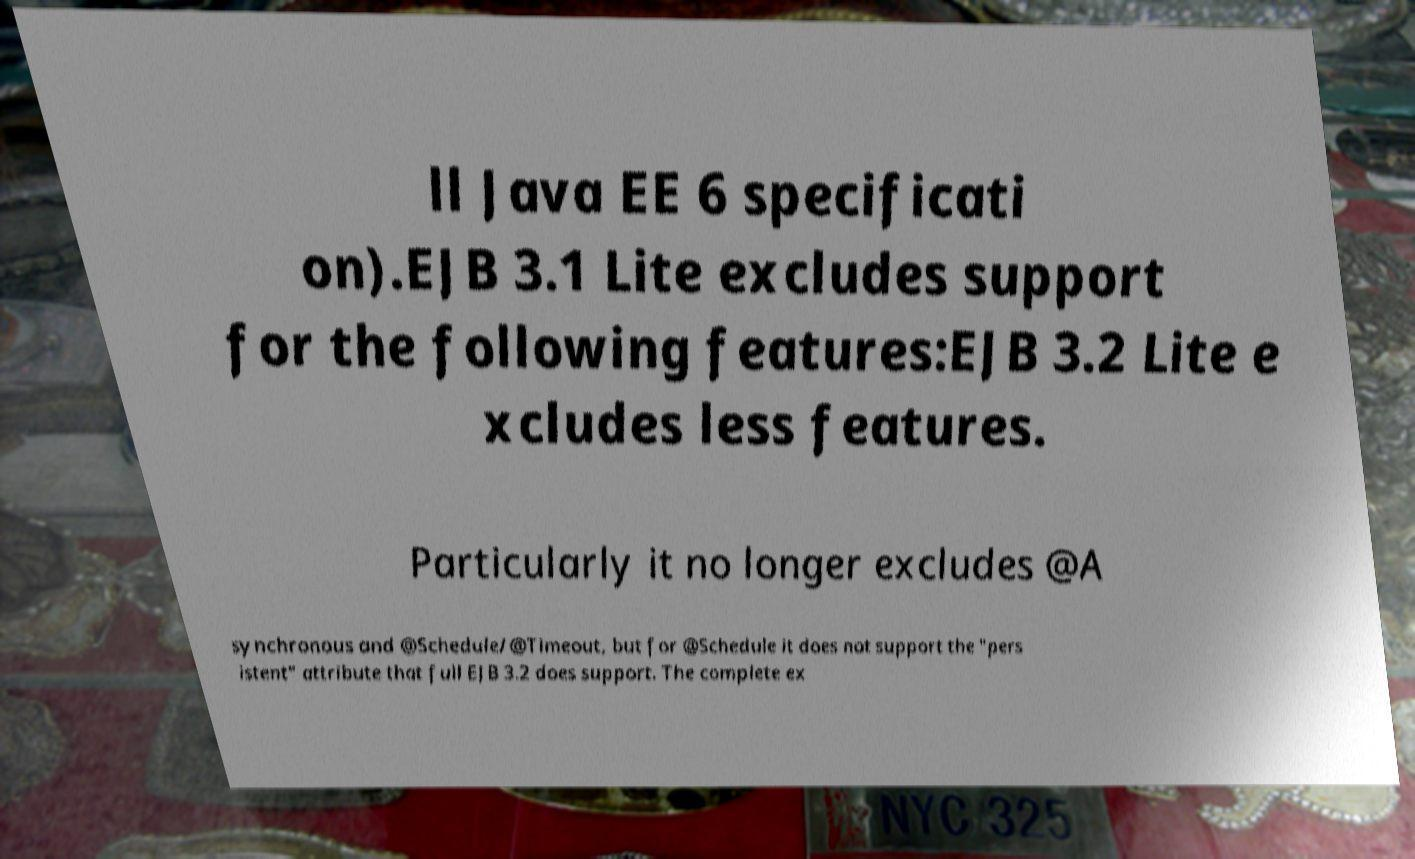Can you read and provide the text displayed in the image?This photo seems to have some interesting text. Can you extract and type it out for me? ll Java EE 6 specificati on).EJB 3.1 Lite excludes support for the following features:EJB 3.2 Lite e xcludes less features. Particularly it no longer excludes @A synchronous and @Schedule/@Timeout, but for @Schedule it does not support the "pers istent" attribute that full EJB 3.2 does support. The complete ex 